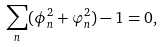<formula> <loc_0><loc_0><loc_500><loc_500>\sum _ { n } ( \phi _ { n } ^ { 2 } + \varphi _ { n } ^ { 2 } ) - 1 = 0 ,</formula> 